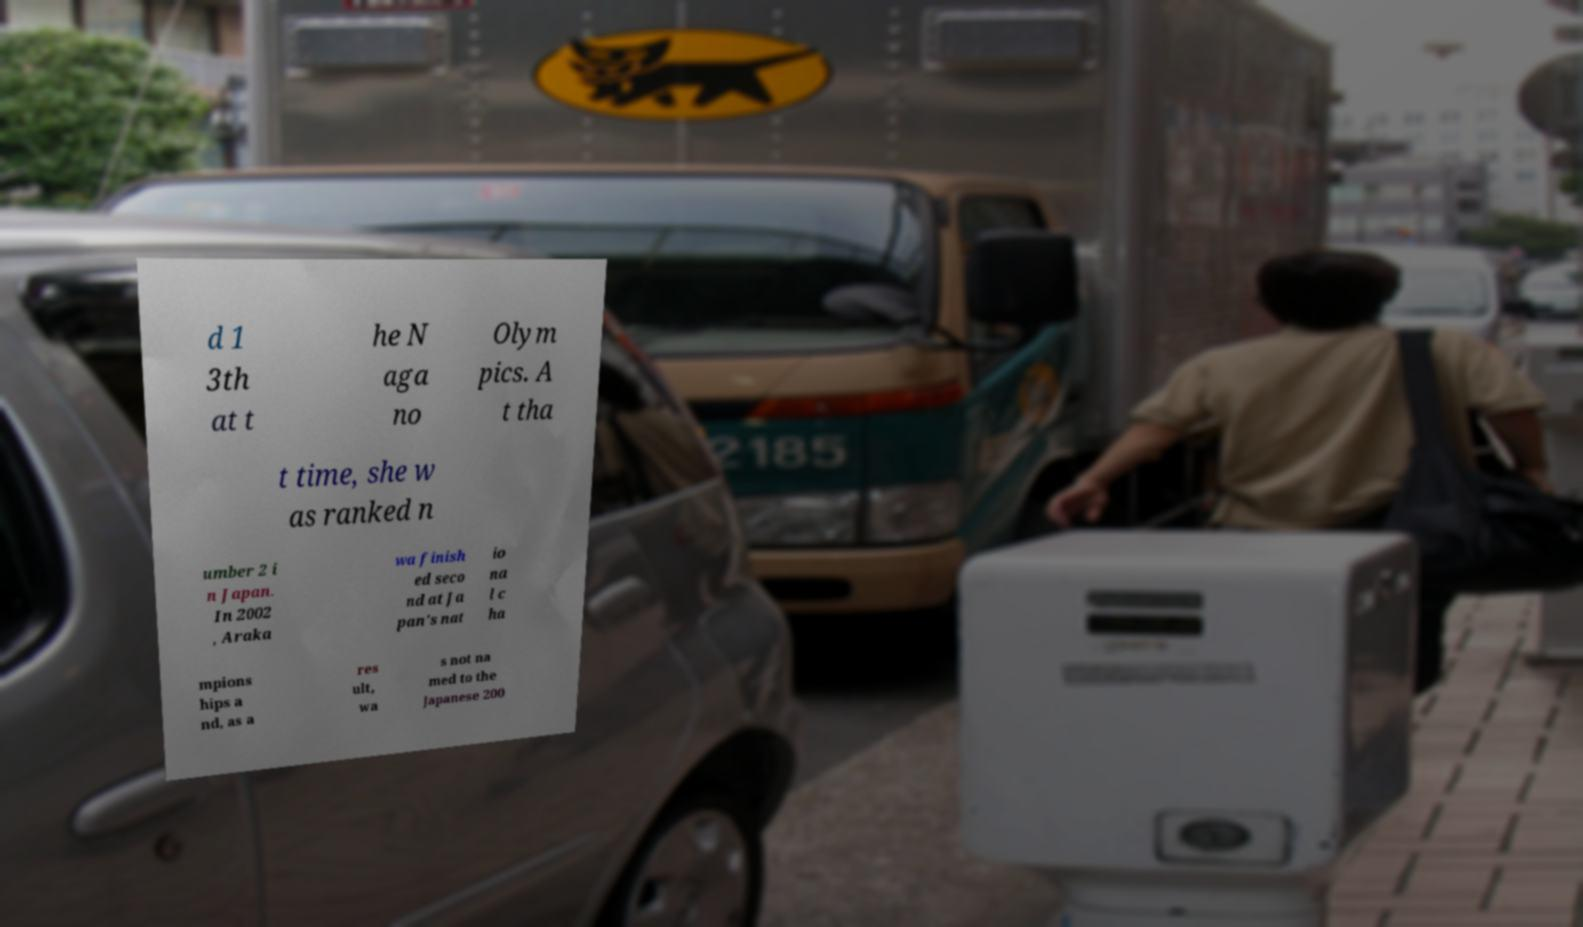Please identify and transcribe the text found in this image. d 1 3th at t he N aga no Olym pics. A t tha t time, she w as ranked n umber 2 i n Japan. In 2002 , Araka wa finish ed seco nd at Ja pan's nat io na l c ha mpions hips a nd, as a res ult, wa s not na med to the Japanese 200 